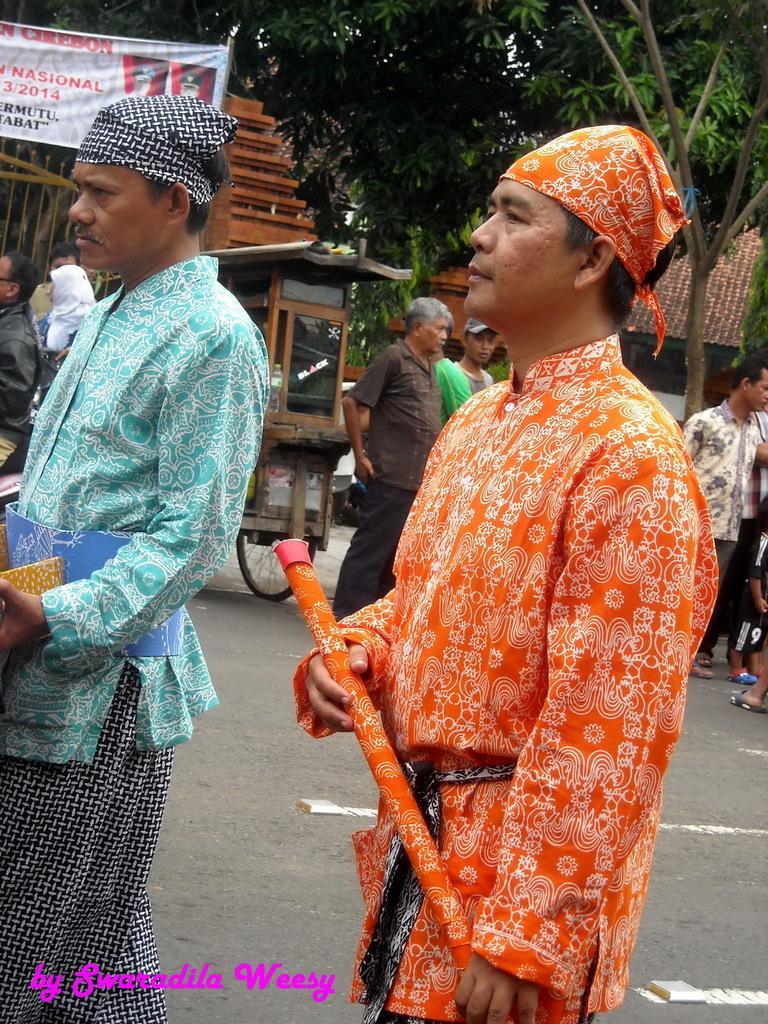Describe this image in one or two sentences. In the image I can see two people holding something and has some cloth on the head and to the side there is a poster and some trees. 